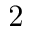Convert formula to latex. <formula><loc_0><loc_0><loc_500><loc_500>2</formula> 